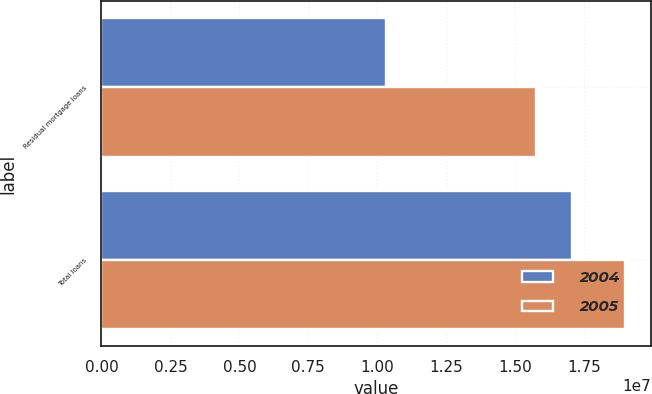Convert chart. <chart><loc_0><loc_0><loc_500><loc_500><stacked_bar_chart><ecel><fcel>Residual mortgage loans<fcel>Total loans<nl><fcel>2004<fcel>1.03008e+07<fcel>1.70432e+07<nl><fcel>2005<fcel>1.5733e+07<fcel>1.89771e+07<nl></chart> 